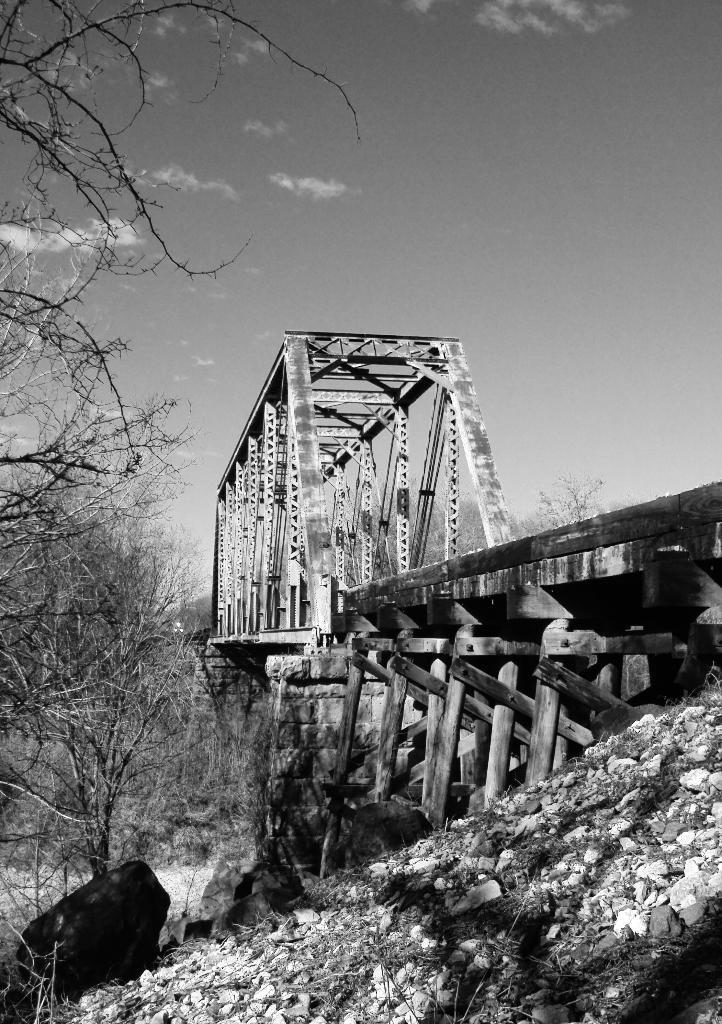What type of structure can be seen in the image? There is a bridge in the image. What other architectural feature is present in the image? There is a wall in the image. What type of natural elements can be seen in the image? There are stones and trees in the image. What is the condition of the sky in the image? The sky is cloudy in the image. What type of print can be seen on the band's uniform in the image? There is no band or uniform present in the image. 